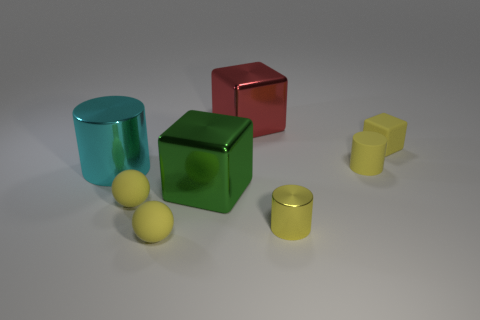Do the tiny metallic cylinder and the matte cylinder have the same color?
Your answer should be compact. Yes. Is the number of tiny yellow matte spheres behind the cyan metallic object less than the number of metal spheres?
Your answer should be compact. No. The other small object that is made of the same material as the red object is what shape?
Your response must be concise. Cylinder. What number of other tiny cubes have the same color as the small matte block?
Your answer should be compact. 0. How many objects are either tiny yellow metallic spheres or tiny rubber balls?
Keep it short and to the point. 2. What is the material of the tiny yellow cylinder that is behind the large metallic cube that is on the left side of the big red object?
Your answer should be compact. Rubber. Are there any small yellow things made of the same material as the big red object?
Offer a very short reply. Yes. The metal object that is to the right of the big object to the right of the large shiny block on the left side of the big red object is what shape?
Offer a terse response. Cylinder. What is the tiny cube made of?
Ensure brevity in your answer.  Rubber. What color is the cylinder that is made of the same material as the tiny cube?
Ensure brevity in your answer.  Yellow. 